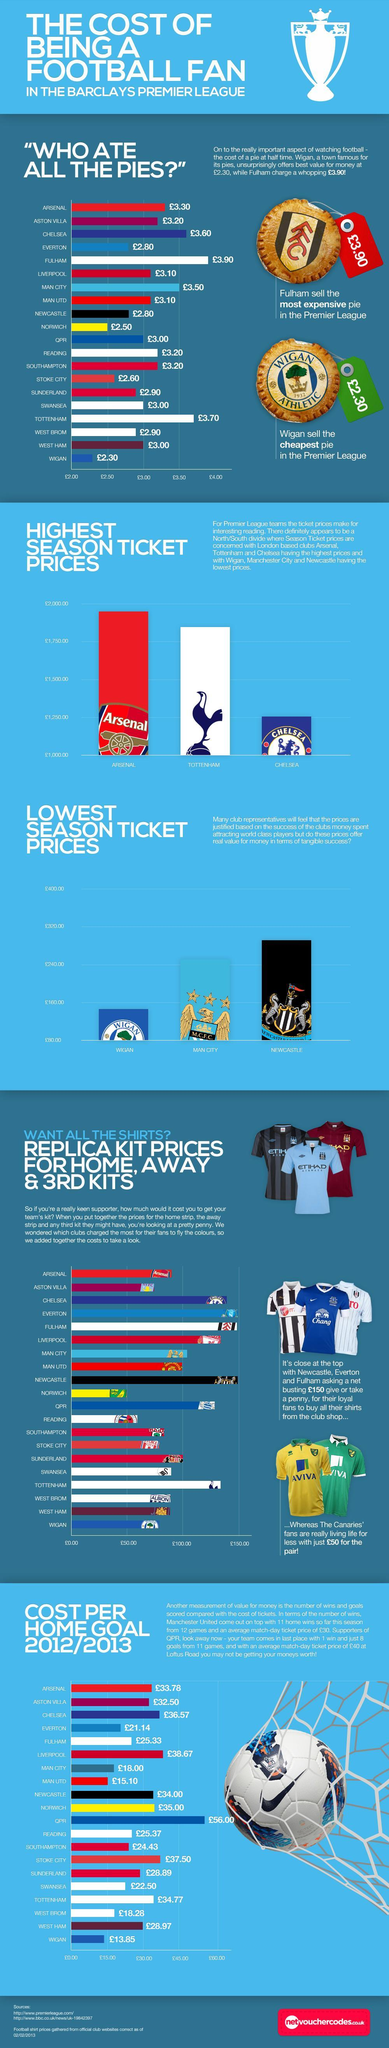How many sources are listed at the bottom?
Answer the question with a short phrase. 2 Which pies supplied at half time cost 3.20 pound? ASTON VILLA, READING, SOUTHAMPTON Which team had the second highest season ticket prices? TOTTENHAM 